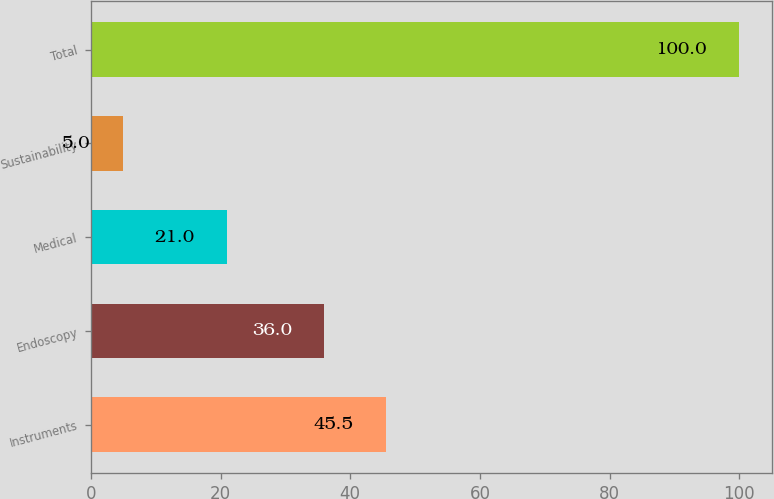Convert chart. <chart><loc_0><loc_0><loc_500><loc_500><bar_chart><fcel>Instruments<fcel>Endoscopy<fcel>Medical<fcel>Sustainability<fcel>Total<nl><fcel>45.5<fcel>36<fcel>21<fcel>5<fcel>100<nl></chart> 